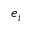<formula> <loc_0><loc_0><loc_500><loc_500>e _ { i }</formula> 